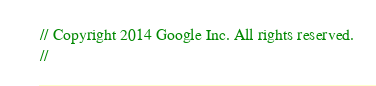Convert code to text. <code><loc_0><loc_0><loc_500><loc_500><_Rust_>// Copyright 2014 Google Inc. All rights reserved.
//</code> 